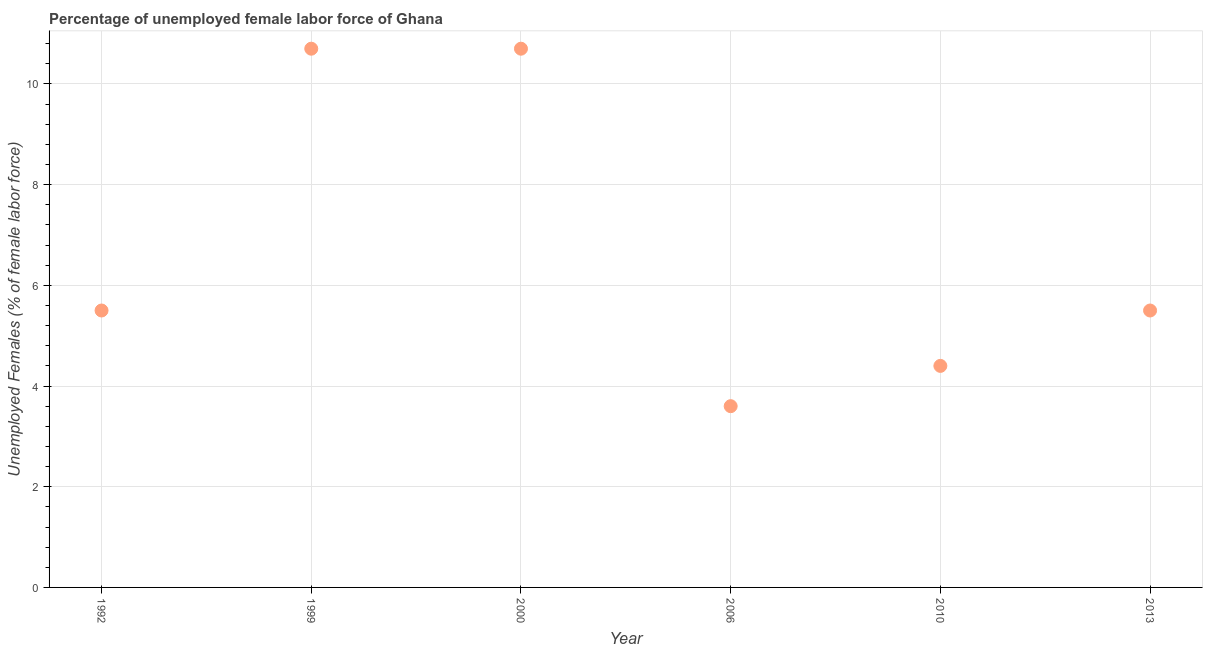What is the total unemployed female labour force in 2010?
Provide a short and direct response. 4.4. Across all years, what is the maximum total unemployed female labour force?
Give a very brief answer. 10.7. Across all years, what is the minimum total unemployed female labour force?
Offer a very short reply. 3.6. What is the sum of the total unemployed female labour force?
Make the answer very short. 40.4. What is the difference between the total unemployed female labour force in 1992 and 2000?
Offer a very short reply. -5.2. What is the average total unemployed female labour force per year?
Your answer should be very brief. 6.73. What is the median total unemployed female labour force?
Give a very brief answer. 5.5. In how many years, is the total unemployed female labour force greater than 6.4 %?
Your answer should be compact. 2. Do a majority of the years between 2013 and 2006 (inclusive) have total unemployed female labour force greater than 3.2 %?
Offer a terse response. No. What is the ratio of the total unemployed female labour force in 2000 to that in 2010?
Give a very brief answer. 2.43. Is the difference between the total unemployed female labour force in 2006 and 2013 greater than the difference between any two years?
Your answer should be very brief. No. What is the difference between the highest and the second highest total unemployed female labour force?
Give a very brief answer. 0. What is the difference between the highest and the lowest total unemployed female labour force?
Provide a succinct answer. 7.1. Does the total unemployed female labour force monotonically increase over the years?
Your answer should be very brief. No. What is the difference between two consecutive major ticks on the Y-axis?
Keep it short and to the point. 2. Are the values on the major ticks of Y-axis written in scientific E-notation?
Keep it short and to the point. No. Does the graph contain any zero values?
Give a very brief answer. No. Does the graph contain grids?
Keep it short and to the point. Yes. What is the title of the graph?
Provide a short and direct response. Percentage of unemployed female labor force of Ghana. What is the label or title of the X-axis?
Provide a short and direct response. Year. What is the label or title of the Y-axis?
Provide a succinct answer. Unemployed Females (% of female labor force). What is the Unemployed Females (% of female labor force) in 1992?
Your answer should be very brief. 5.5. What is the Unemployed Females (% of female labor force) in 1999?
Provide a succinct answer. 10.7. What is the Unemployed Females (% of female labor force) in 2000?
Offer a very short reply. 10.7. What is the Unemployed Females (% of female labor force) in 2006?
Ensure brevity in your answer.  3.6. What is the Unemployed Females (% of female labor force) in 2010?
Give a very brief answer. 4.4. What is the Unemployed Females (% of female labor force) in 2013?
Your answer should be very brief. 5.5. What is the difference between the Unemployed Females (% of female labor force) in 1992 and 1999?
Offer a very short reply. -5.2. What is the difference between the Unemployed Females (% of female labor force) in 1992 and 2000?
Your answer should be compact. -5.2. What is the difference between the Unemployed Females (% of female labor force) in 1999 and 2006?
Offer a terse response. 7.1. What is the difference between the Unemployed Females (% of female labor force) in 1999 and 2013?
Offer a very short reply. 5.2. What is the difference between the Unemployed Females (% of female labor force) in 2000 and 2006?
Your answer should be compact. 7.1. What is the difference between the Unemployed Females (% of female labor force) in 2000 and 2013?
Keep it short and to the point. 5.2. What is the difference between the Unemployed Females (% of female labor force) in 2006 and 2010?
Provide a succinct answer. -0.8. What is the difference between the Unemployed Females (% of female labor force) in 2006 and 2013?
Provide a short and direct response. -1.9. What is the difference between the Unemployed Females (% of female labor force) in 2010 and 2013?
Offer a terse response. -1.1. What is the ratio of the Unemployed Females (% of female labor force) in 1992 to that in 1999?
Provide a short and direct response. 0.51. What is the ratio of the Unemployed Females (% of female labor force) in 1992 to that in 2000?
Your answer should be very brief. 0.51. What is the ratio of the Unemployed Females (% of female labor force) in 1992 to that in 2006?
Offer a terse response. 1.53. What is the ratio of the Unemployed Females (% of female labor force) in 1992 to that in 2010?
Your response must be concise. 1.25. What is the ratio of the Unemployed Females (% of female labor force) in 1999 to that in 2000?
Your answer should be very brief. 1. What is the ratio of the Unemployed Females (% of female labor force) in 1999 to that in 2006?
Provide a succinct answer. 2.97. What is the ratio of the Unemployed Females (% of female labor force) in 1999 to that in 2010?
Your response must be concise. 2.43. What is the ratio of the Unemployed Females (% of female labor force) in 1999 to that in 2013?
Your answer should be very brief. 1.95. What is the ratio of the Unemployed Females (% of female labor force) in 2000 to that in 2006?
Make the answer very short. 2.97. What is the ratio of the Unemployed Females (% of female labor force) in 2000 to that in 2010?
Keep it short and to the point. 2.43. What is the ratio of the Unemployed Females (% of female labor force) in 2000 to that in 2013?
Provide a short and direct response. 1.95. What is the ratio of the Unemployed Females (% of female labor force) in 2006 to that in 2010?
Make the answer very short. 0.82. What is the ratio of the Unemployed Females (% of female labor force) in 2006 to that in 2013?
Offer a very short reply. 0.66. What is the ratio of the Unemployed Females (% of female labor force) in 2010 to that in 2013?
Keep it short and to the point. 0.8. 